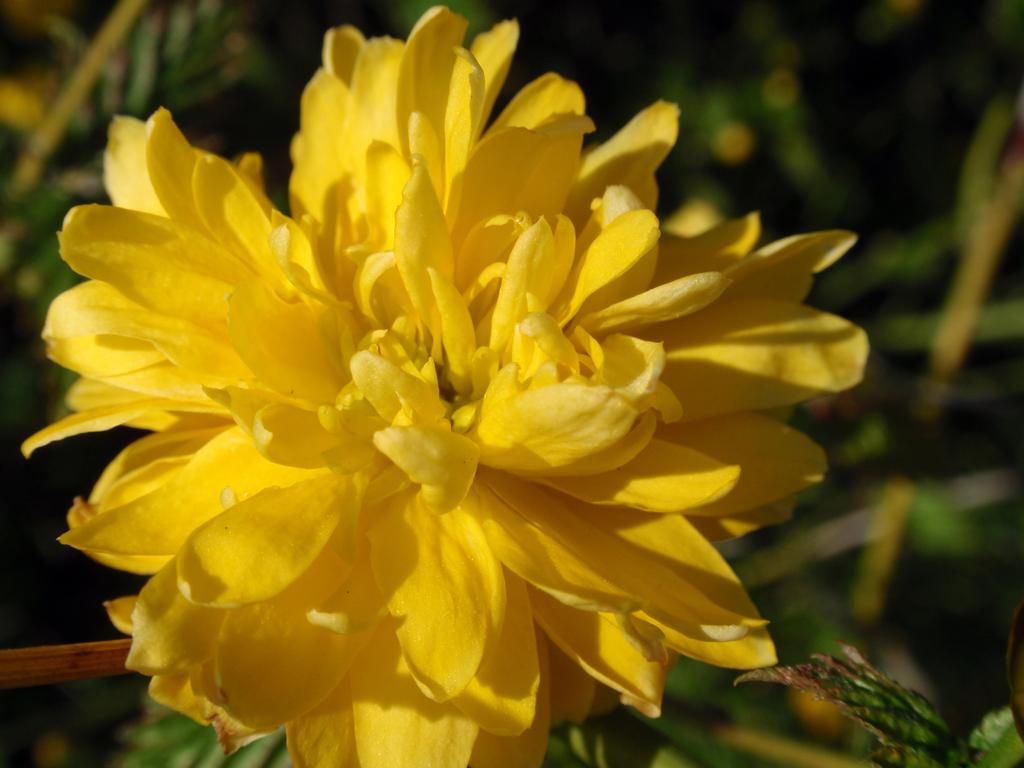What is the main subject in the center of the image? There is a flower in the center of the image. What can be seen in the background of the image? There are plants in the background of the image. What type of engine is powering the flower in the image? There is no engine present in the image, as it features a flower and plants. 